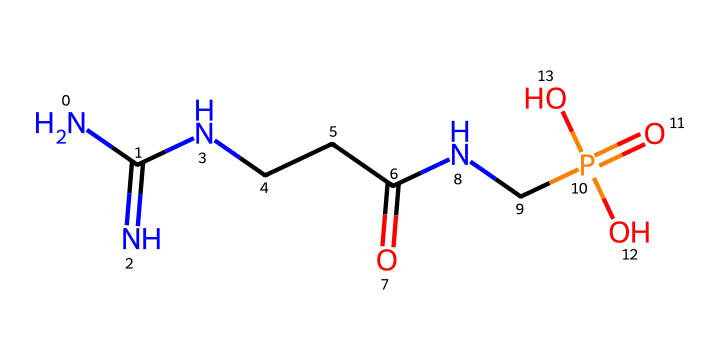What is the main functional group present in phosphocreatine? The main functional group in phosphocreatine is the phosphate group, which is present as P(=O)(O)O. This is identified from the phosphorus atom connected to four oxygen atoms, making it characteristic of phosphonates or phosphates.
Answer: phosphate group How many nitrogen atoms are in the structure of phosphocreatine? In the SMILES representation, there are three nitrogen atoms (N) indicated, counted from their occurrences in the structure. The three nitrogen atoms are clearly visible in the sequence.
Answer: three What type of bond connects the nitrogen atoms to the carbon atoms? The bond connecting the nitrogen atoms to the carbon atoms is a single covalent bond, indicated by the lack of double bonds between them in the structure. Each nitrogen is connected to a carbon atom through a single bond.
Answer: single covalent bond Which component of phosphocreatine is responsible for energy storage? The component responsible for energy storage is the phosphate group, as it can release energy when the phosphate bond is broken, regenerating ATP during exercise. This is characteristic of phosphocreatine as a high-energy compound.
Answer: phosphate group What role does phosphocreatine play in muscle cells? Phosphocreatine acts as a reservoir for regenerating ATP during short bursts of intense exercise, helping to quickly replenish energy stores in muscle cells. This is crucial as ATP is needed for muscle contraction and energy metabolism.
Answer: energy reservoir Does phosphocreatine contain any sulfur atoms? No, phosphocreatine does not contain any sulfur atoms, as determined from the SMILES; there are only nitrogen, oxygen, phosphorus, and carbon atoms present in the molecule. Therefore, sulfur is absent.
Answer: no 